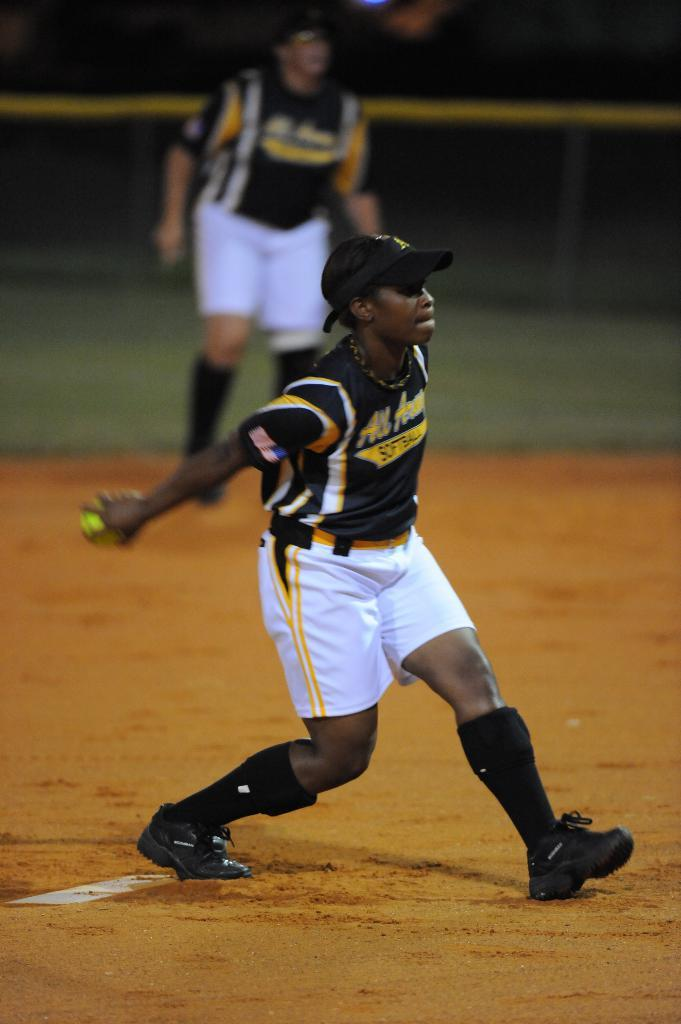Provide a one-sentence caption for the provided image. Athlete wearing a white and black jersey that says All American on it. 